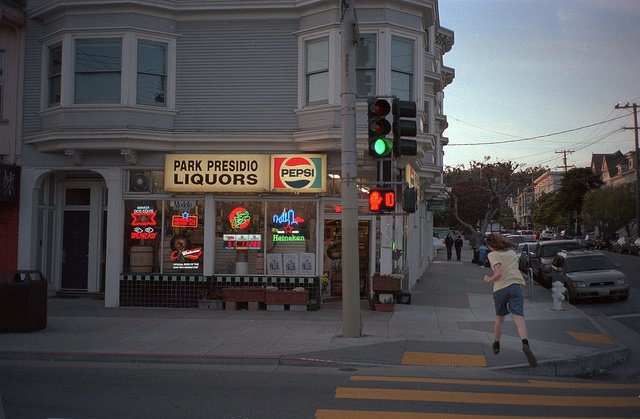Describe the objects in this image and their specific colors. I can see people in black and gray tones, car in black and gray tones, traffic light in black, gray, darkgreen, and lightgreen tones, traffic light in black, gray, and purple tones, and truck in black and gray tones in this image. 